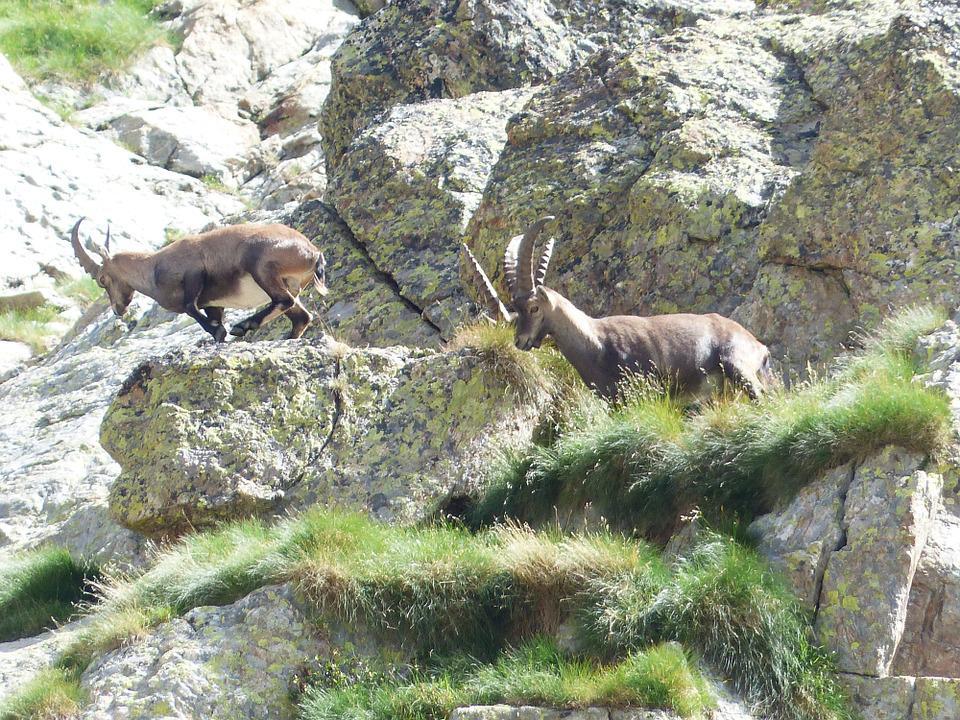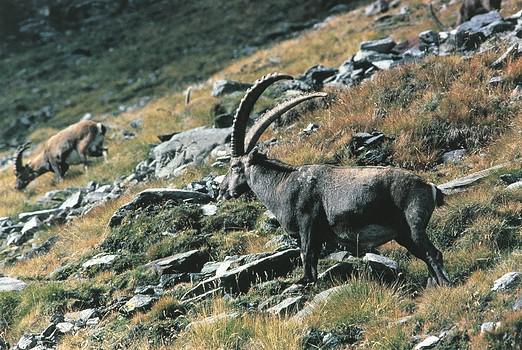The first image is the image on the left, the second image is the image on the right. Given the left and right images, does the statement "There are exactly four animals in the image on the left." hold true? Answer yes or no. No. 